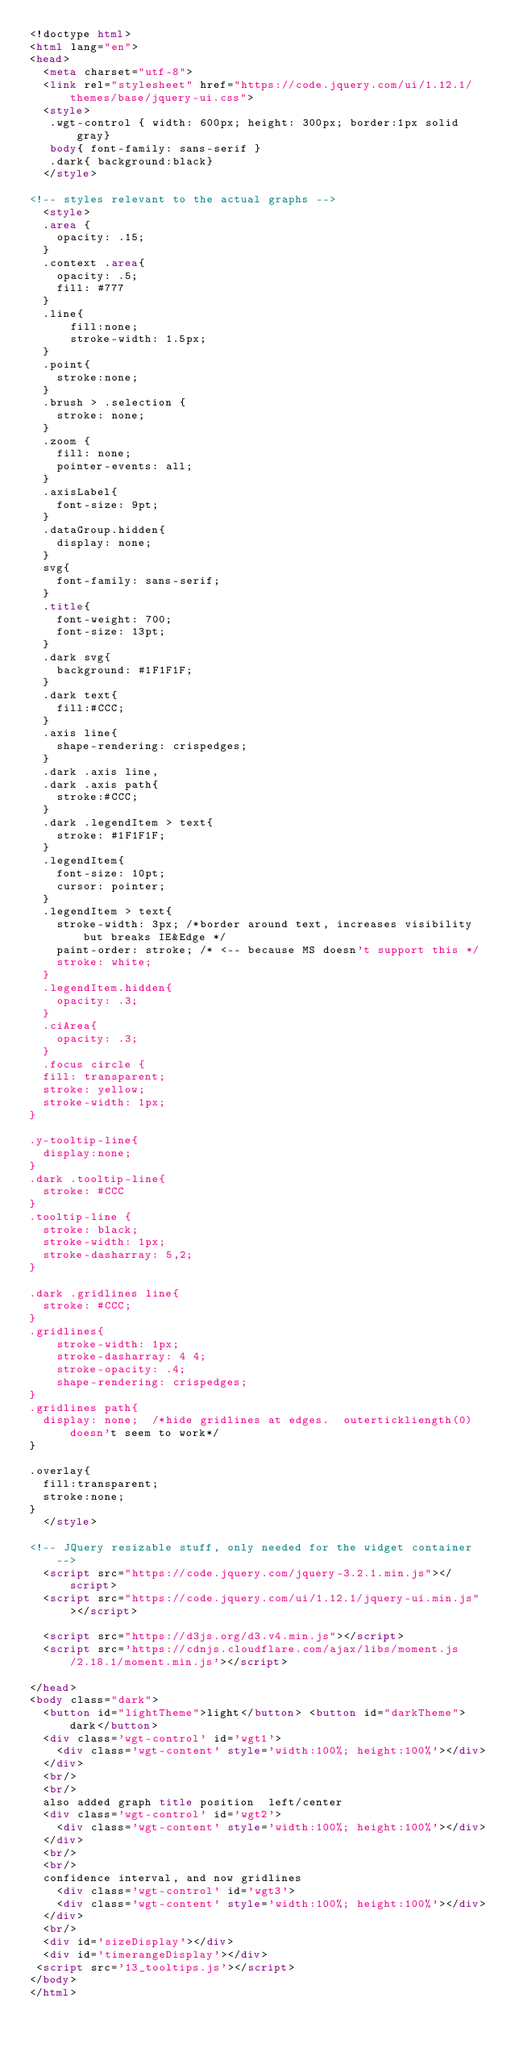<code> <loc_0><loc_0><loc_500><loc_500><_HTML_><!doctype html>
<html lang="en">
<head>
  <meta charset="utf-8">
  <link rel="stylesheet" href="https://code.jquery.com/ui/1.12.1/themes/base/jquery-ui.css">
  <style>
   .wgt-control { width: 600px; height: 300px; border:1px solid gray}
   body{ font-family: sans-serif }
   .dark{ background:black}
  </style>

<!-- styles relevant to the actual graphs -->
  <style>
  .area {
    opacity: .15;
  }
  .context .area{
    opacity: .5;
    fill: #777
  }
  .line{
      fill:none;
      stroke-width: 1.5px;
  }
  .point{
    stroke:none;
  }
  .brush > .selection {
    stroke: none;
  }
  .zoom {
    fill: none;
    pointer-events: all;
  }
  .axisLabel{
    font-size: 9pt;
  }
  .dataGroup.hidden{
    display: none;
  }
  svg{
    font-family: sans-serif;
  }
  .title{
    font-weight: 700;
    font-size: 13pt;
  }
  .dark svg{
    background: #1F1F1F;
  }
  .dark text{
    fill:#CCC;
  }
  .axis line{
    shape-rendering: crispedges;
  }
  .dark .axis line,
  .dark .axis path{
    stroke:#CCC;
  }
  .dark .legendItem > text{
    stroke: #1F1F1F;
  }
  .legendItem{
    font-size: 10pt;
    cursor: pointer;
  }
  .legendItem > text{
    stroke-width: 3px; /*border around text, increases visibility but breaks IE&Edge */
    paint-order: stroke; /* <-- because MS doesn't support this */ 
    stroke: white;
  }
  .legendItem.hidden{
    opacity: .3;
  }
  .ciArea{
    opacity: .3;
  }
  .focus circle {
  fill: transparent;
  stroke: yellow;
  stroke-width: 1px;
}

.y-tooltip-line{
  display:none;
}
.dark .tooltip-line{
  stroke: #CCC
}
.tooltip-line {
  stroke: black;
  stroke-width: 1px;
  stroke-dasharray: 5,2;
}

.dark .gridlines line{
  stroke: #CCC;
}
.gridlines{
    stroke-width: 1px;
    stroke-dasharray: 4 4;
    stroke-opacity: .4;
    shape-rendering: crispedges;
}
.gridlines path{
  display: none;  /*hide gridlines at edges.  outertickliength(0) doesn't seem to work*/
}

.overlay{
  fill:transparent;
  stroke:none;
}
  </style>

<!-- JQuery resizable stuff, only needed for the widget container -->
  <script src="https://code.jquery.com/jquery-3.2.1.min.js"></script>
  <script src="https://code.jquery.com/ui/1.12.1/jquery-ui.min.js"></script>

  <script src="https://d3js.org/d3.v4.min.js"></script>
  <script src='https://cdnjs.cloudflare.com/ajax/libs/moment.js/2.18.1/moment.min.js'></script>
  
</head>
<body class="dark">
  <button id="lightTheme">light</button> <button id="darkTheme">dark</button>
  <div class='wgt-control' id='wgt1'>
    <div class='wgt-content' style='width:100%; height:100%'></div>
  </div>
  <br/>
  <br/>
  also added graph title position  left/center
  <div class='wgt-control' id='wgt2'>
    <div class='wgt-content' style='width:100%; height:100%'></div>
  </div>
  <br/>
  <br/>
  confidence interval, and now gridlines
    <div class='wgt-control' id='wgt3'>
    <div class='wgt-content' style='width:100%; height:100%'></div>
  </div>
  <br/>
  <div id='sizeDisplay'></div>
  <div id='timerangeDisplay'></div>
 <script src='13_tooltips.js'></script>
</body>
</html></code> 